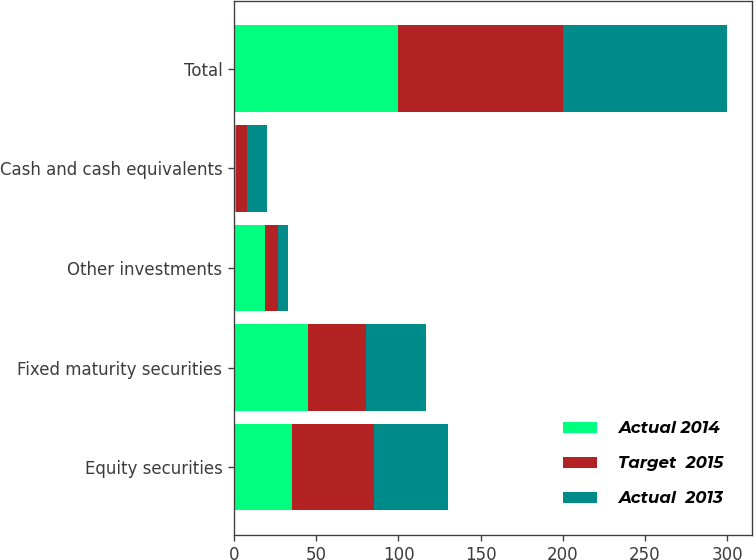Convert chart to OTSL. <chart><loc_0><loc_0><loc_500><loc_500><stacked_bar_chart><ecel><fcel>Equity securities<fcel>Fixed maturity securities<fcel>Other investments<fcel>Cash and cash equivalents<fcel>Total<nl><fcel>Actual 2014<fcel>35<fcel>45<fcel>19<fcel>1<fcel>100<nl><fcel>Target  2015<fcel>50<fcel>35<fcel>8<fcel>7<fcel>100<nl><fcel>Actual  2013<fcel>45<fcel>37<fcel>6<fcel>12<fcel>100<nl></chart> 